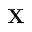Convert formula to latex. <formula><loc_0><loc_0><loc_500><loc_500>{ X }</formula> 